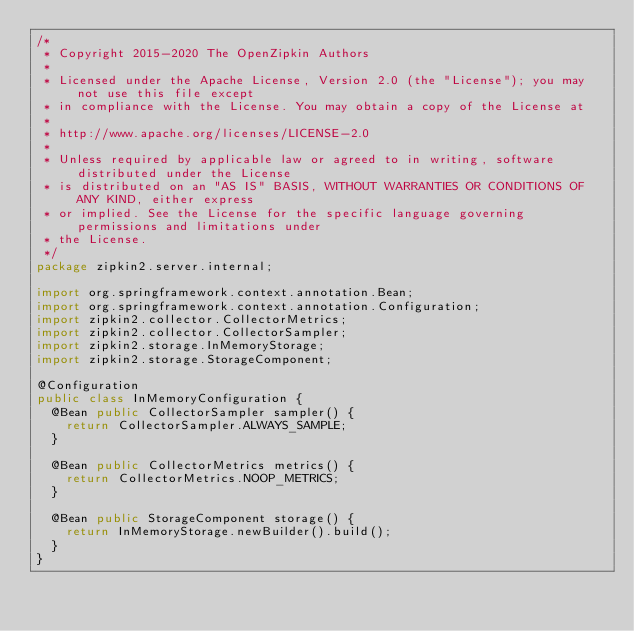Convert code to text. <code><loc_0><loc_0><loc_500><loc_500><_Java_>/*
 * Copyright 2015-2020 The OpenZipkin Authors
 *
 * Licensed under the Apache License, Version 2.0 (the "License"); you may not use this file except
 * in compliance with the License. You may obtain a copy of the License at
 *
 * http://www.apache.org/licenses/LICENSE-2.0
 *
 * Unless required by applicable law or agreed to in writing, software distributed under the License
 * is distributed on an "AS IS" BASIS, WITHOUT WARRANTIES OR CONDITIONS OF ANY KIND, either express
 * or implied. See the License for the specific language governing permissions and limitations under
 * the License.
 */
package zipkin2.server.internal;

import org.springframework.context.annotation.Bean;
import org.springframework.context.annotation.Configuration;
import zipkin2.collector.CollectorMetrics;
import zipkin2.collector.CollectorSampler;
import zipkin2.storage.InMemoryStorage;
import zipkin2.storage.StorageComponent;

@Configuration
public class InMemoryConfiguration {
  @Bean public CollectorSampler sampler() {
    return CollectorSampler.ALWAYS_SAMPLE;
  }

  @Bean public CollectorMetrics metrics() {
    return CollectorMetrics.NOOP_METRICS;
  }

  @Bean public StorageComponent storage() {
    return InMemoryStorage.newBuilder().build();
  }
}
</code> 